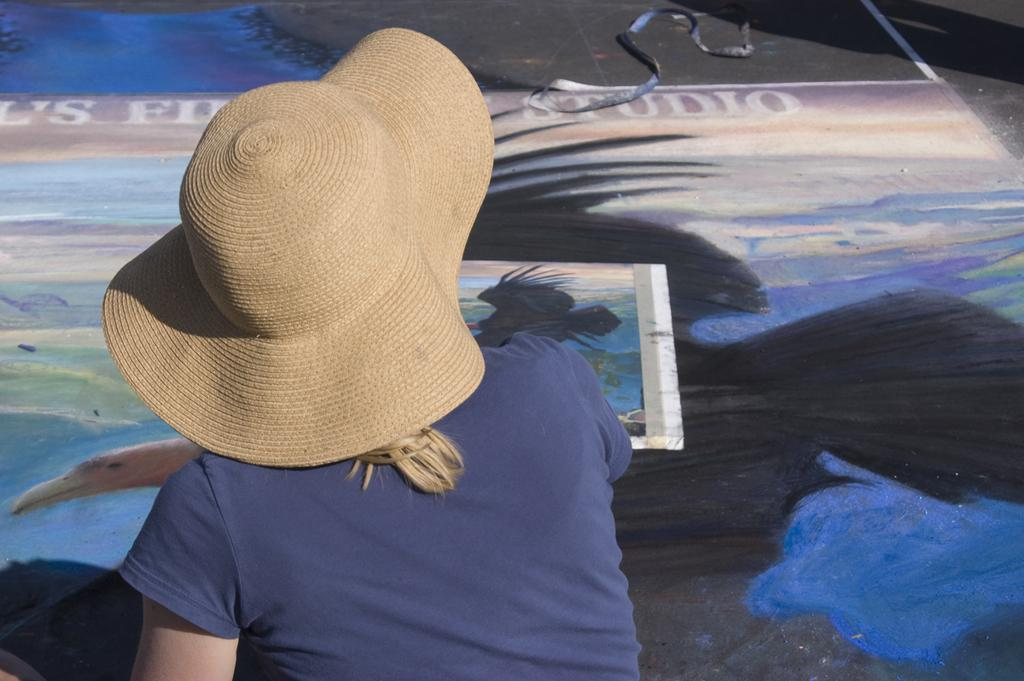Who is present in the image? There is a woman in the image. What is the woman wearing on her head? The woman is wearing a cap on her head. What is on the floor in front of the woman? There is a painting on the floor in front of the woman. What can be seen at the top of the image? A rope is visible at the top of the image. What type of flesh can be seen in the image? There is no flesh visible in the image; it only features a woman, a cap, a painting, and a rope. How many waves are present in the image? There are no waves present in the image. 